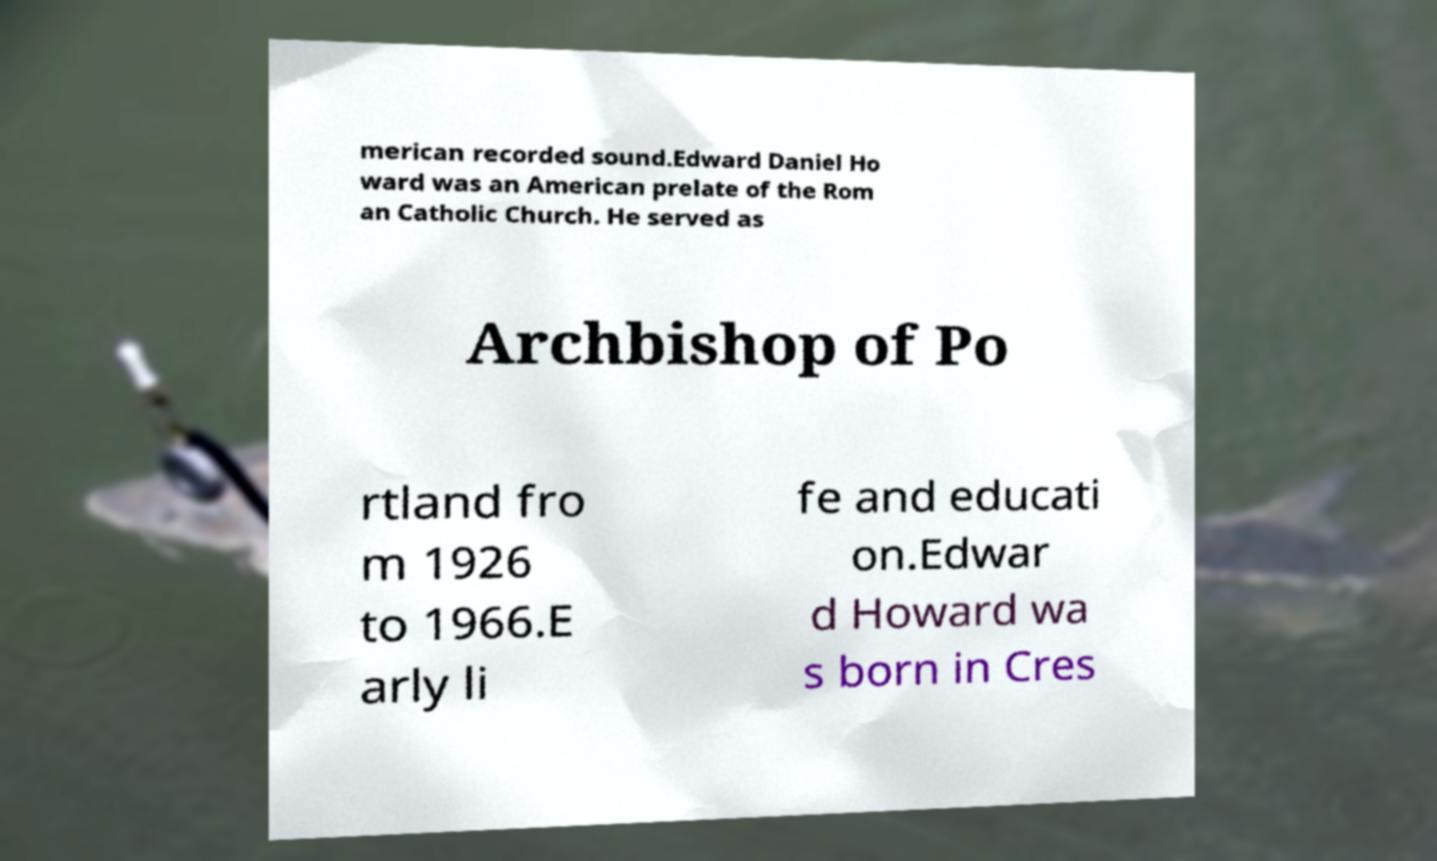What messages or text are displayed in this image? I need them in a readable, typed format. merican recorded sound.Edward Daniel Ho ward was an American prelate of the Rom an Catholic Church. He served as Archbishop of Po rtland fro m 1926 to 1966.E arly li fe and educati on.Edwar d Howard wa s born in Cres 